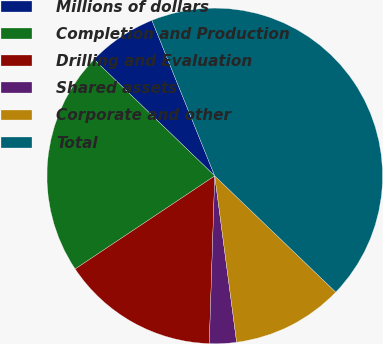<chart> <loc_0><loc_0><loc_500><loc_500><pie_chart><fcel>Millions of dollars<fcel>Completion and Production<fcel>Drilling and Evaluation<fcel>Shared assets<fcel>Corporate and other<fcel>Total<nl><fcel>6.67%<fcel>21.58%<fcel>15.12%<fcel>2.6%<fcel>10.74%<fcel>43.29%<nl></chart> 